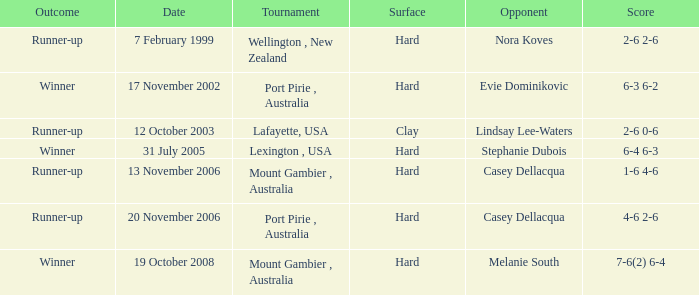When is a competitor of evie dominikovic? 17 November 2002. 